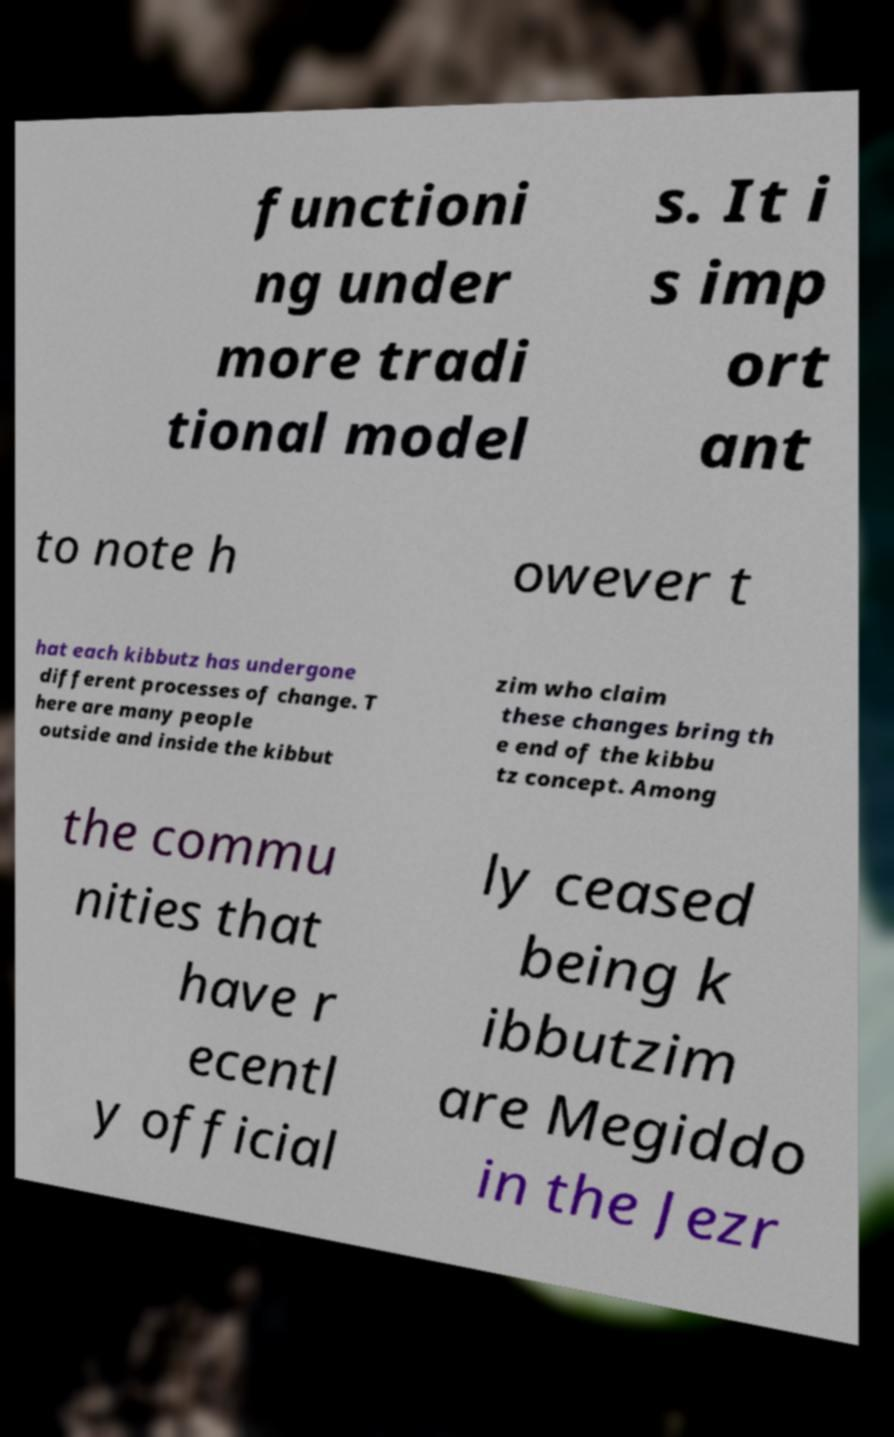Could you extract and type out the text from this image? functioni ng under more tradi tional model s. It i s imp ort ant to note h owever t hat each kibbutz has undergone different processes of change. T here are many people outside and inside the kibbut zim who claim these changes bring th e end of the kibbu tz concept. Among the commu nities that have r ecentl y official ly ceased being k ibbutzim are Megiddo in the Jezr 